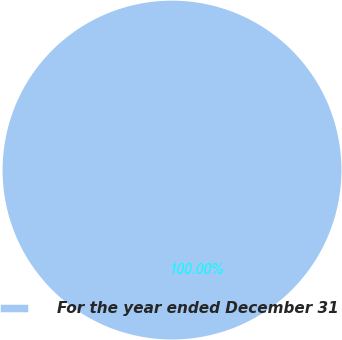<chart> <loc_0><loc_0><loc_500><loc_500><pie_chart><fcel>For the year ended December 31<nl><fcel>100.0%<nl></chart> 